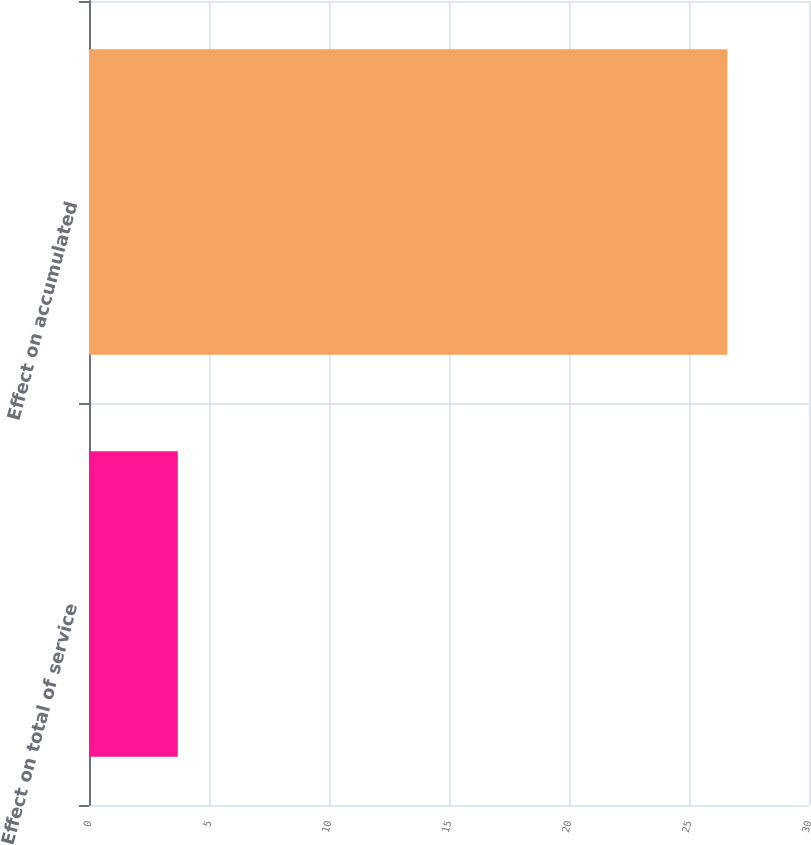Convert chart. <chart><loc_0><loc_0><loc_500><loc_500><bar_chart><fcel>Effect on total of service<fcel>Effect on accumulated<nl><fcel>3.7<fcel>26.6<nl></chart> 